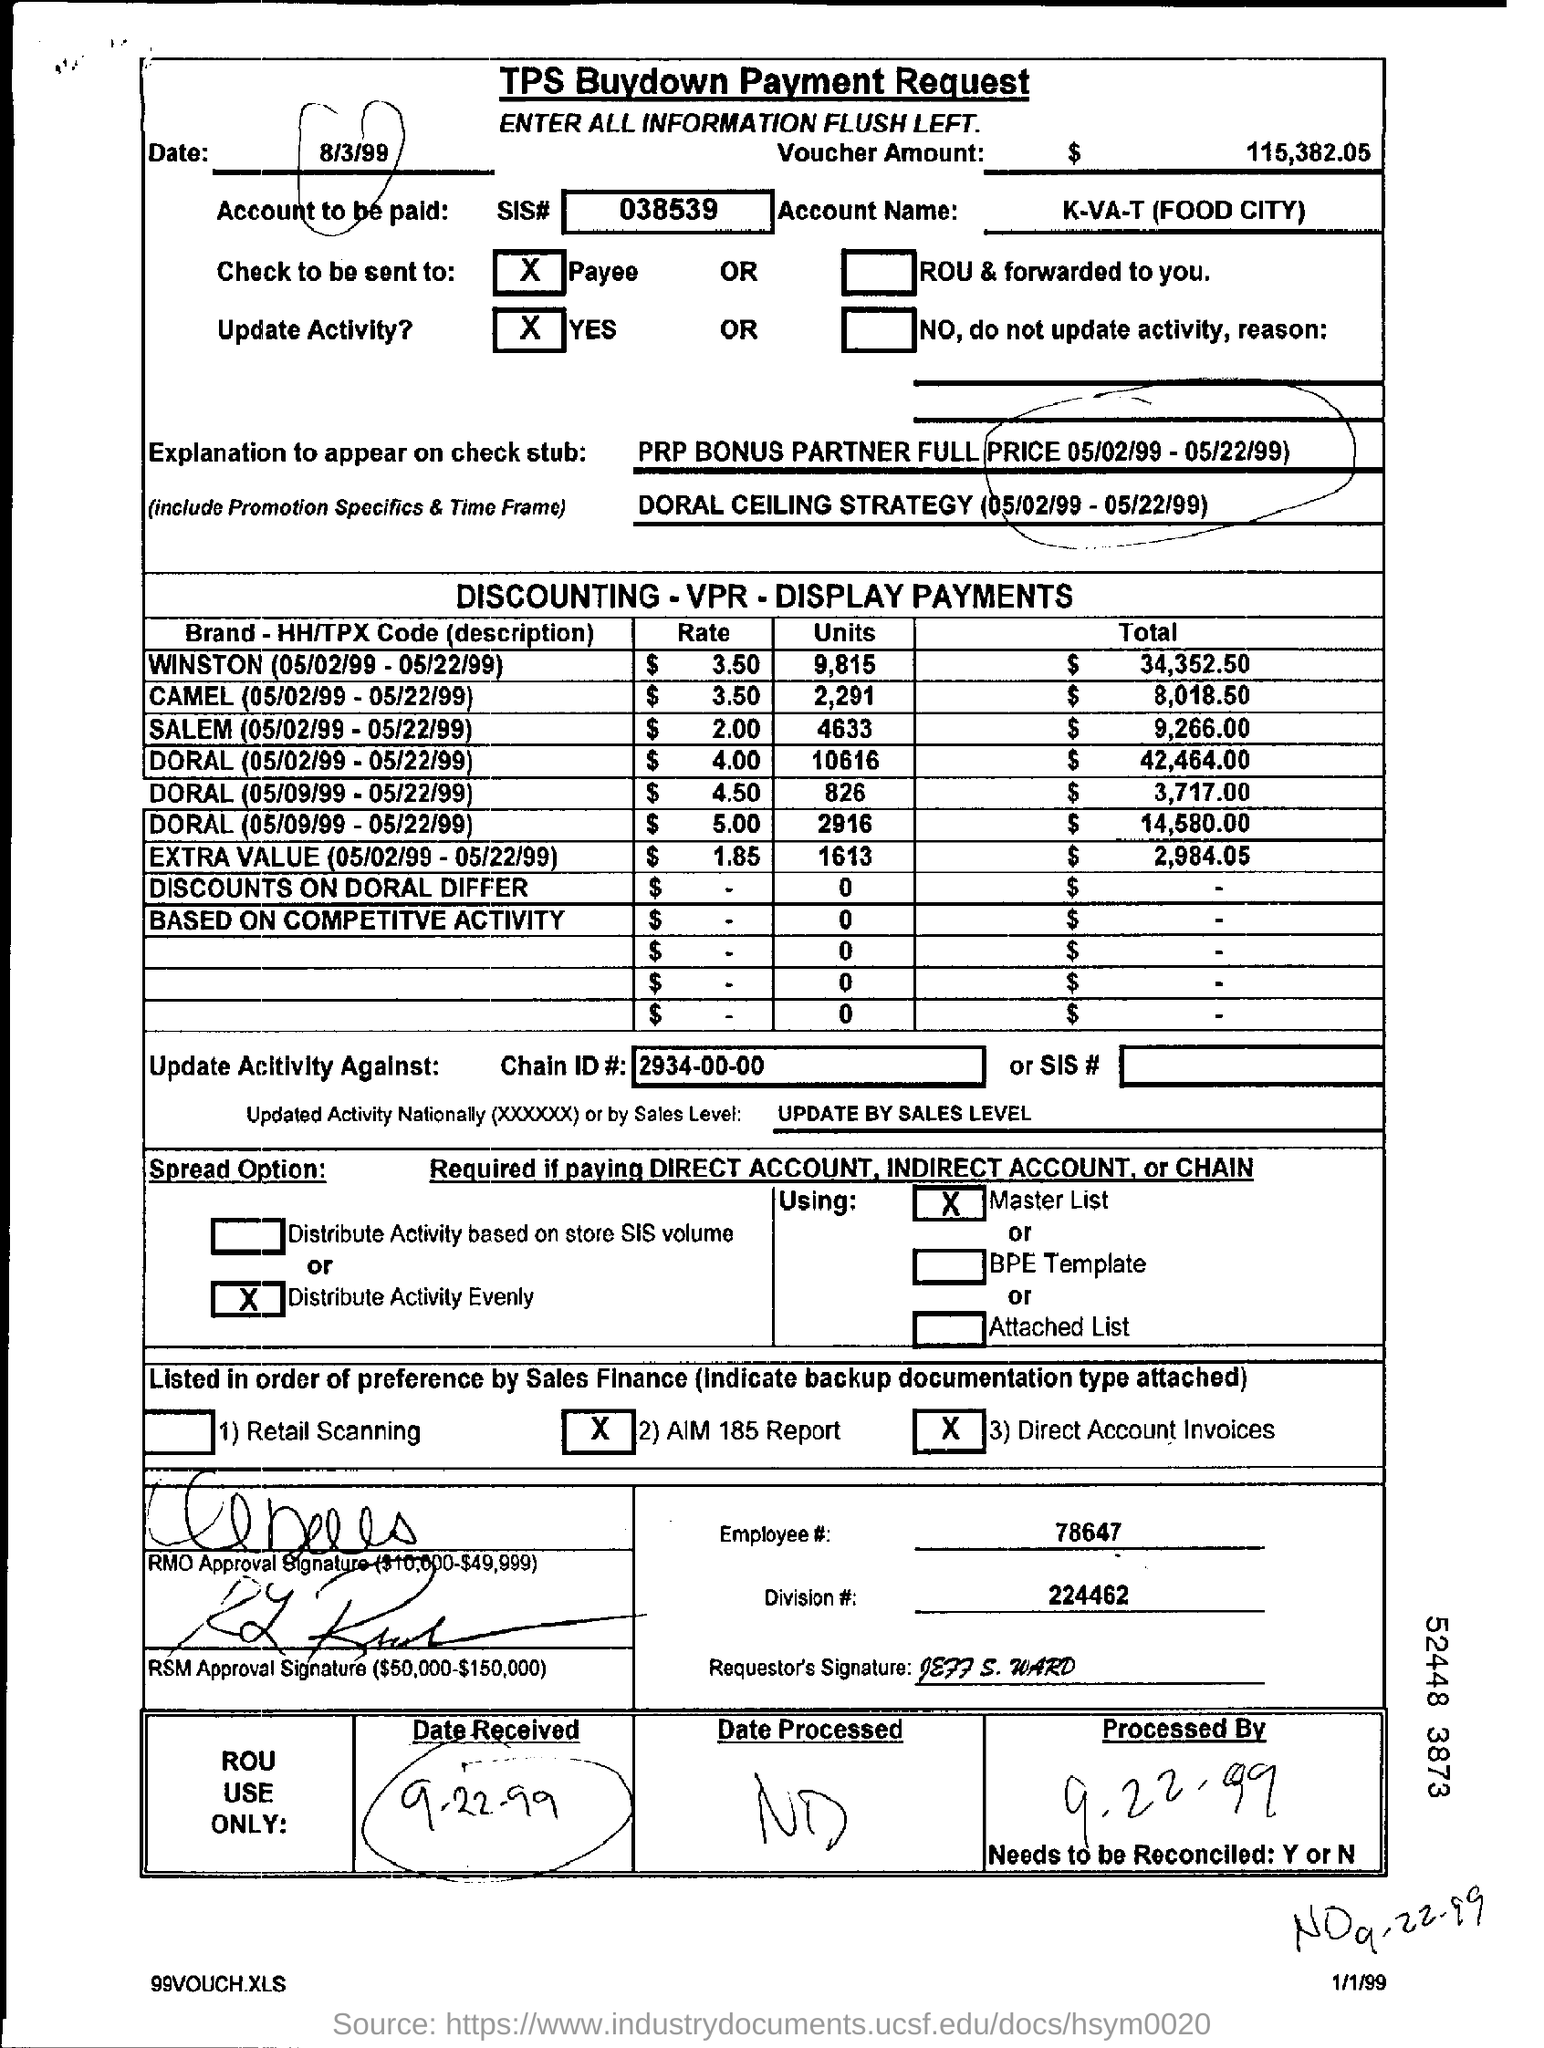What is the Division #? The Division # is 224462, as indicated near the bottom of the TPS Buydown Payment Request document, under the section for employee details. 